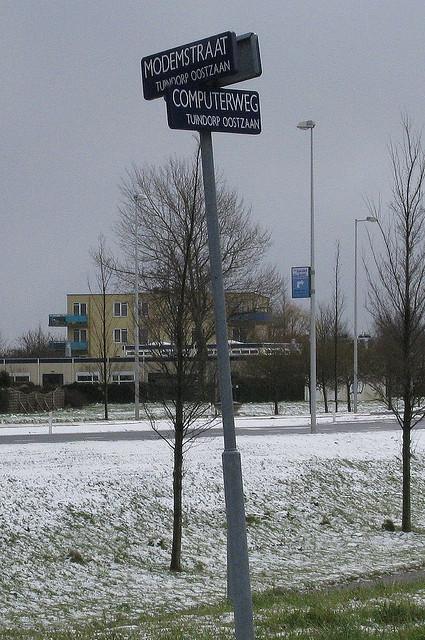What city is this?
Short answer required. Can't tell. What street is this picture taken on?
Be succinct. Modemstraat. What time of year was this picture taken?
Be succinct. Winter. Does any part of this area light up at night?
Concise answer only. Yes. What does the sign say?
Write a very short answer. Computerweg. What are the blue signs for?
Quick response, please. Parking. How many trees are on this field?
Give a very brief answer. 2. 